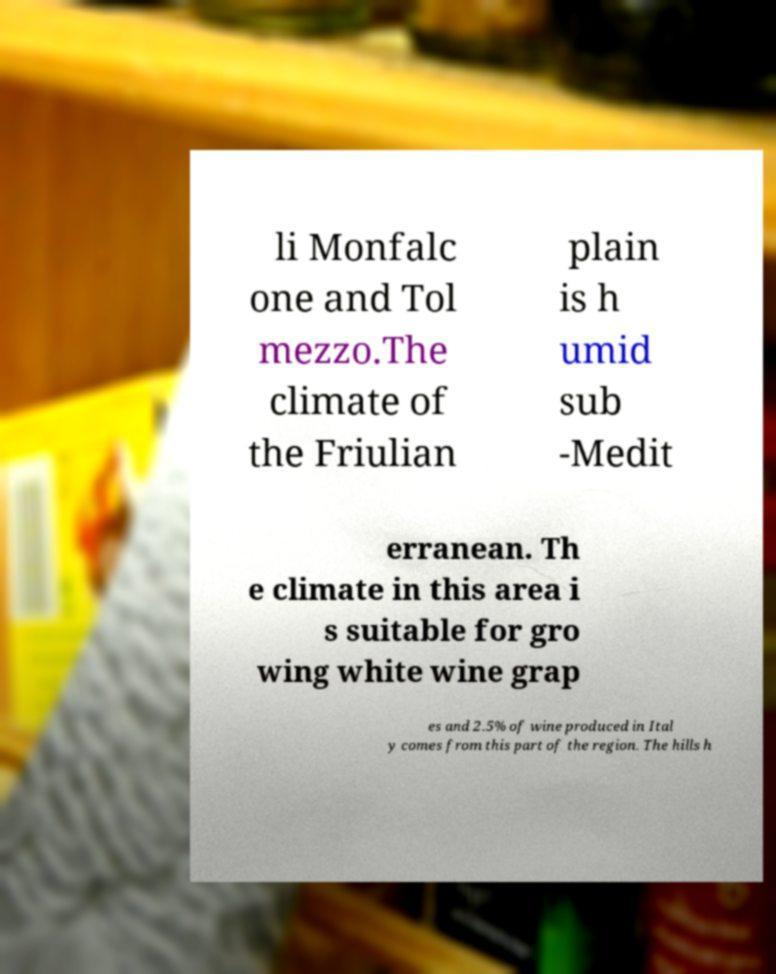Please identify and transcribe the text found in this image. li Monfalc one and Tol mezzo.The climate of the Friulian plain is h umid sub -Medit erranean. Th e climate in this area i s suitable for gro wing white wine grap es and 2.5% of wine produced in Ital y comes from this part of the region. The hills h 